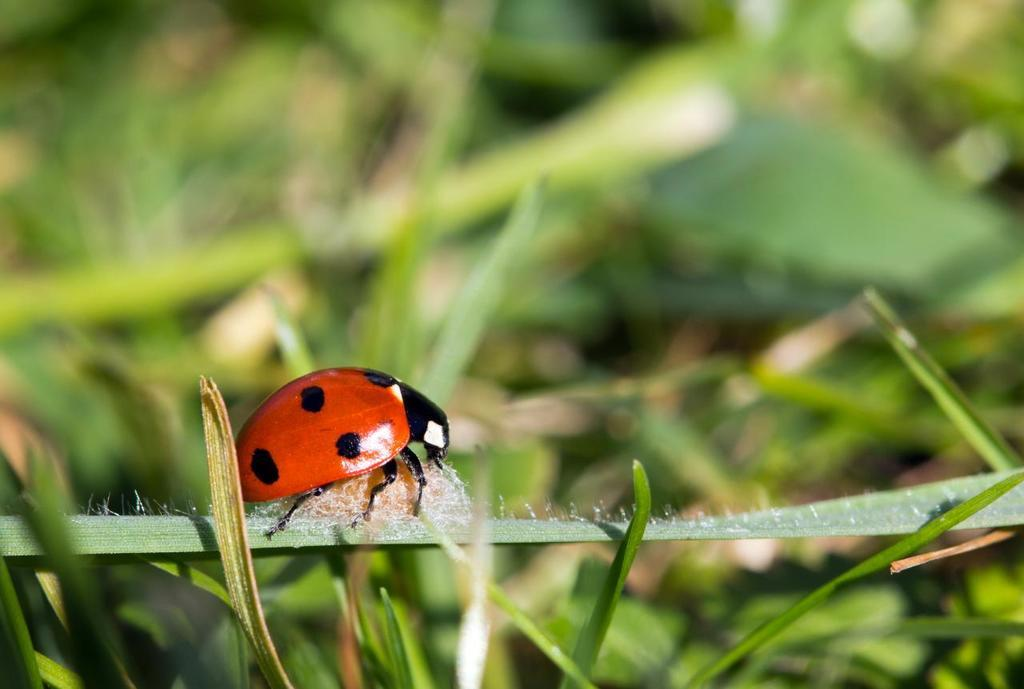What type of creature is present in the image? There is an insect in the image. What colors can be seen on the insect? The insect has red and black colors. What type of environment is visible in the background of the image? There is grass visible in the background of the image. What type of cushion is being used by the insect in the image? There is no cushion present in the image; it features an insect with red and black colors against a grassy background. What is the value of the screw that the insect is holding in the image? There is no screw present in the image; it only features an insect with red and black colors against a grassy background. 